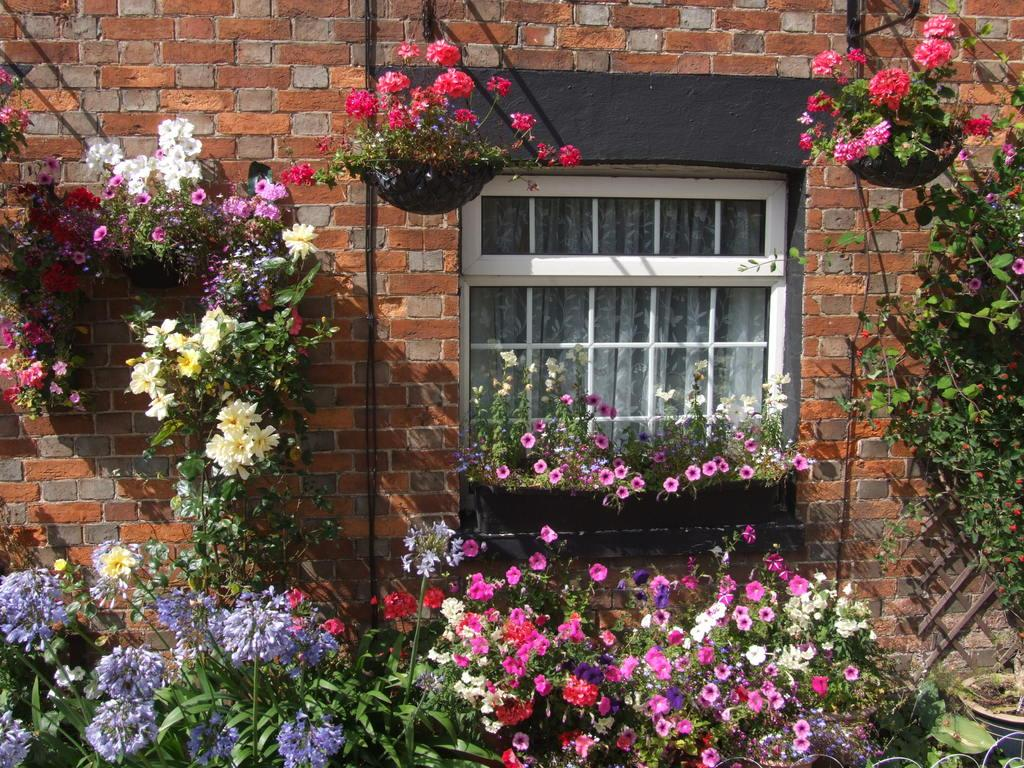What is a prominent feature in the image? There is a window in the image. What type of wall does the window belong to? The window is on a brick wall. What can be seen around the window? There are many flower plants around the window. What type of cake is being served in the wilderness near the window? There is no cake or wilderness present in the image; it only features a window on a brick wall with flower plants around it. 